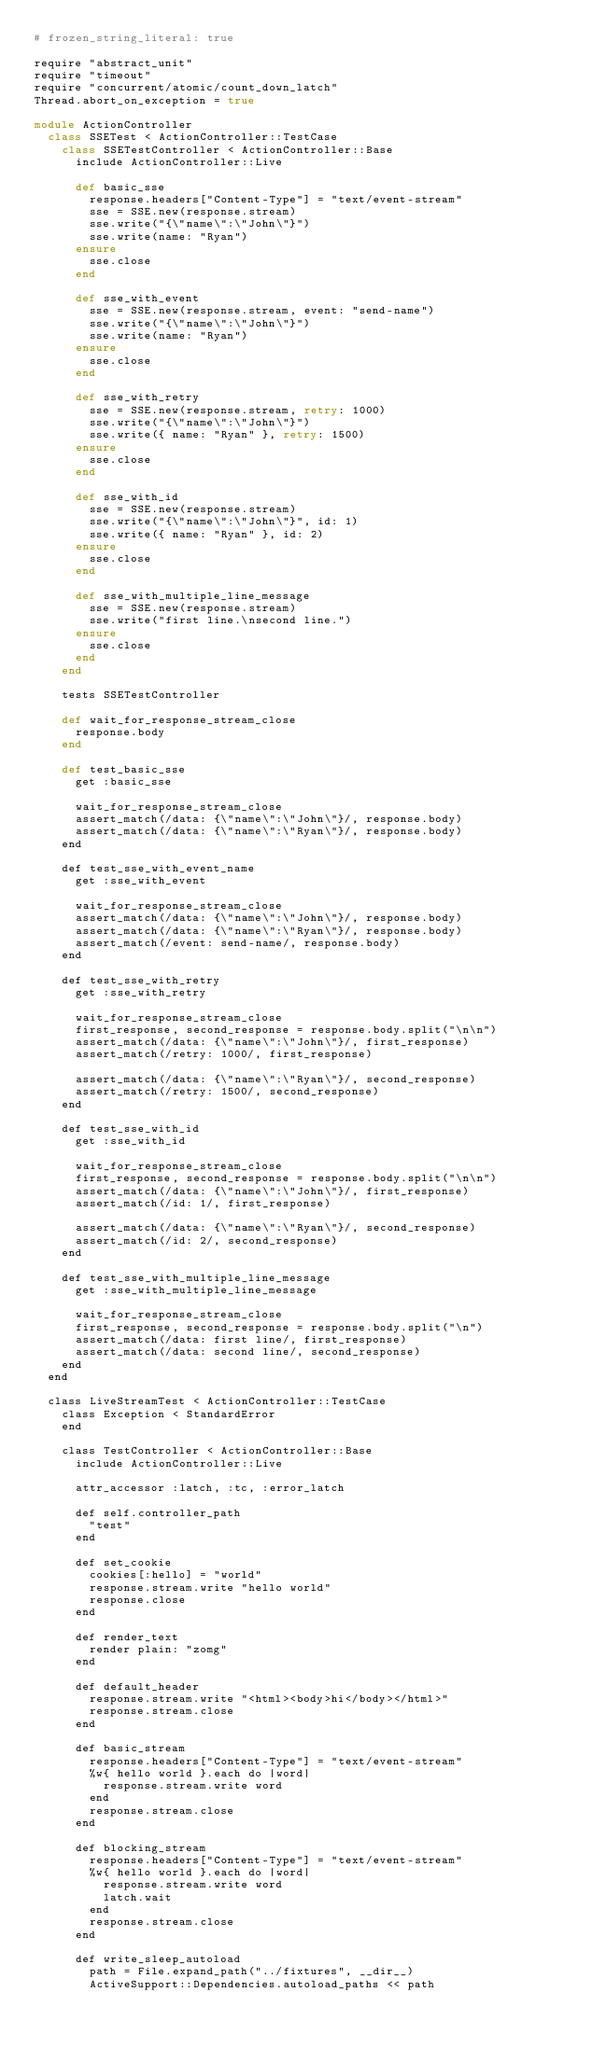Convert code to text. <code><loc_0><loc_0><loc_500><loc_500><_Ruby_># frozen_string_literal: true

require "abstract_unit"
require "timeout"
require "concurrent/atomic/count_down_latch"
Thread.abort_on_exception = true

module ActionController
  class SSETest < ActionController::TestCase
    class SSETestController < ActionController::Base
      include ActionController::Live

      def basic_sse
        response.headers["Content-Type"] = "text/event-stream"
        sse = SSE.new(response.stream)
        sse.write("{\"name\":\"John\"}")
        sse.write(name: "Ryan")
      ensure
        sse.close
      end

      def sse_with_event
        sse = SSE.new(response.stream, event: "send-name")
        sse.write("{\"name\":\"John\"}")
        sse.write(name: "Ryan")
      ensure
        sse.close
      end

      def sse_with_retry
        sse = SSE.new(response.stream, retry: 1000)
        sse.write("{\"name\":\"John\"}")
        sse.write({ name: "Ryan" }, retry: 1500)
      ensure
        sse.close
      end

      def sse_with_id
        sse = SSE.new(response.stream)
        sse.write("{\"name\":\"John\"}", id: 1)
        sse.write({ name: "Ryan" }, id: 2)
      ensure
        sse.close
      end

      def sse_with_multiple_line_message
        sse = SSE.new(response.stream)
        sse.write("first line.\nsecond line.")
      ensure
        sse.close
      end
    end

    tests SSETestController

    def wait_for_response_stream_close
      response.body
    end

    def test_basic_sse
      get :basic_sse

      wait_for_response_stream_close
      assert_match(/data: {\"name\":\"John\"}/, response.body)
      assert_match(/data: {\"name\":\"Ryan\"}/, response.body)
    end

    def test_sse_with_event_name
      get :sse_with_event

      wait_for_response_stream_close
      assert_match(/data: {\"name\":\"John\"}/, response.body)
      assert_match(/data: {\"name\":\"Ryan\"}/, response.body)
      assert_match(/event: send-name/, response.body)
    end

    def test_sse_with_retry
      get :sse_with_retry

      wait_for_response_stream_close
      first_response, second_response = response.body.split("\n\n")
      assert_match(/data: {\"name\":\"John\"}/, first_response)
      assert_match(/retry: 1000/, first_response)

      assert_match(/data: {\"name\":\"Ryan\"}/, second_response)
      assert_match(/retry: 1500/, second_response)
    end

    def test_sse_with_id
      get :sse_with_id

      wait_for_response_stream_close
      first_response, second_response = response.body.split("\n\n")
      assert_match(/data: {\"name\":\"John\"}/, first_response)
      assert_match(/id: 1/, first_response)

      assert_match(/data: {\"name\":\"Ryan\"}/, second_response)
      assert_match(/id: 2/, second_response)
    end

    def test_sse_with_multiple_line_message
      get :sse_with_multiple_line_message

      wait_for_response_stream_close
      first_response, second_response = response.body.split("\n")
      assert_match(/data: first line/, first_response)
      assert_match(/data: second line/, second_response)
    end
  end

  class LiveStreamTest < ActionController::TestCase
    class Exception < StandardError
    end

    class TestController < ActionController::Base
      include ActionController::Live

      attr_accessor :latch, :tc, :error_latch

      def self.controller_path
        "test"
      end

      def set_cookie
        cookies[:hello] = "world"
        response.stream.write "hello world"
        response.close
      end

      def render_text
        render plain: "zomg"
      end

      def default_header
        response.stream.write "<html><body>hi</body></html>"
        response.stream.close
      end

      def basic_stream
        response.headers["Content-Type"] = "text/event-stream"
        %w{ hello world }.each do |word|
          response.stream.write word
        end
        response.stream.close
      end

      def blocking_stream
        response.headers["Content-Type"] = "text/event-stream"
        %w{ hello world }.each do |word|
          response.stream.write word
          latch.wait
        end
        response.stream.close
      end

      def write_sleep_autoload
        path = File.expand_path("../fixtures", __dir__)
        ActiveSupport::Dependencies.autoload_paths << path
</code> 